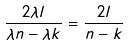<formula> <loc_0><loc_0><loc_500><loc_500>\frac { 2 \lambda l } { \lambda n - \lambda k } = \frac { 2 l } { n - k }</formula> 